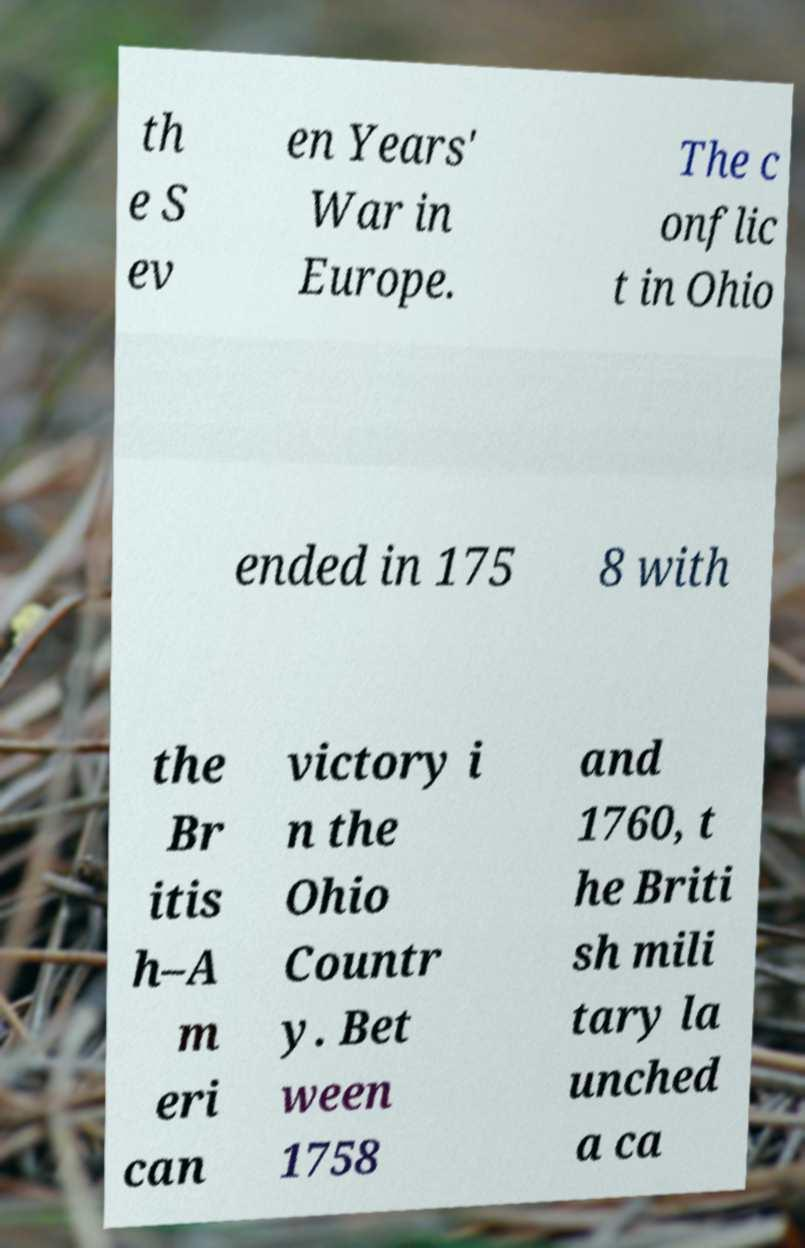Could you extract and type out the text from this image? th e S ev en Years' War in Europe. The c onflic t in Ohio ended in 175 8 with the Br itis h–A m eri can victory i n the Ohio Countr y. Bet ween 1758 and 1760, t he Briti sh mili tary la unched a ca 